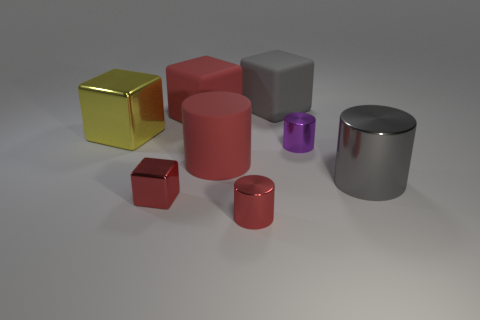Subtract all metal cylinders. How many cylinders are left? 1 Add 2 cyan shiny spheres. How many objects exist? 10 Subtract all gray cylinders. How many cylinders are left? 3 Add 6 gray metal things. How many gray metal things exist? 7 Subtract 0 cyan cylinders. How many objects are left? 8 Subtract 3 cubes. How many cubes are left? 1 Subtract all cyan cubes. Subtract all yellow balls. How many cubes are left? 4 Subtract all green balls. How many blue blocks are left? 0 Subtract all large brown matte things. Subtract all small red metal cylinders. How many objects are left? 7 Add 7 matte things. How many matte things are left? 10 